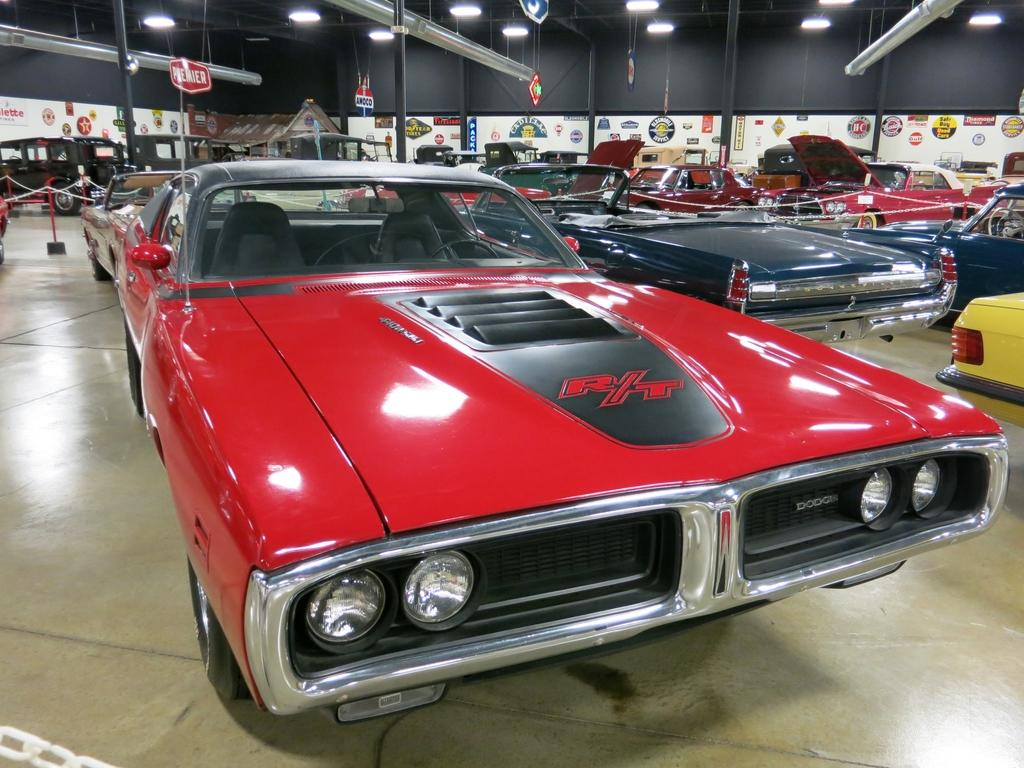What can be seen in the image related to transportation? There are vehicles parked in the image. What is the surface on which the vehicles are parked? The vehicles are parked on a surface. What can be seen in the background of the image related to advertising or events? There are banners, poles, hoardings, and rods in the background of the image. What is visible at the top of the image? There are lights visible at the top of the image. What type of society is depicted in the image? There is no depiction of a society in the image; it primarily features parked vehicles and background elements. What are the dogs doing in the image? There are no dogs present in the image. 